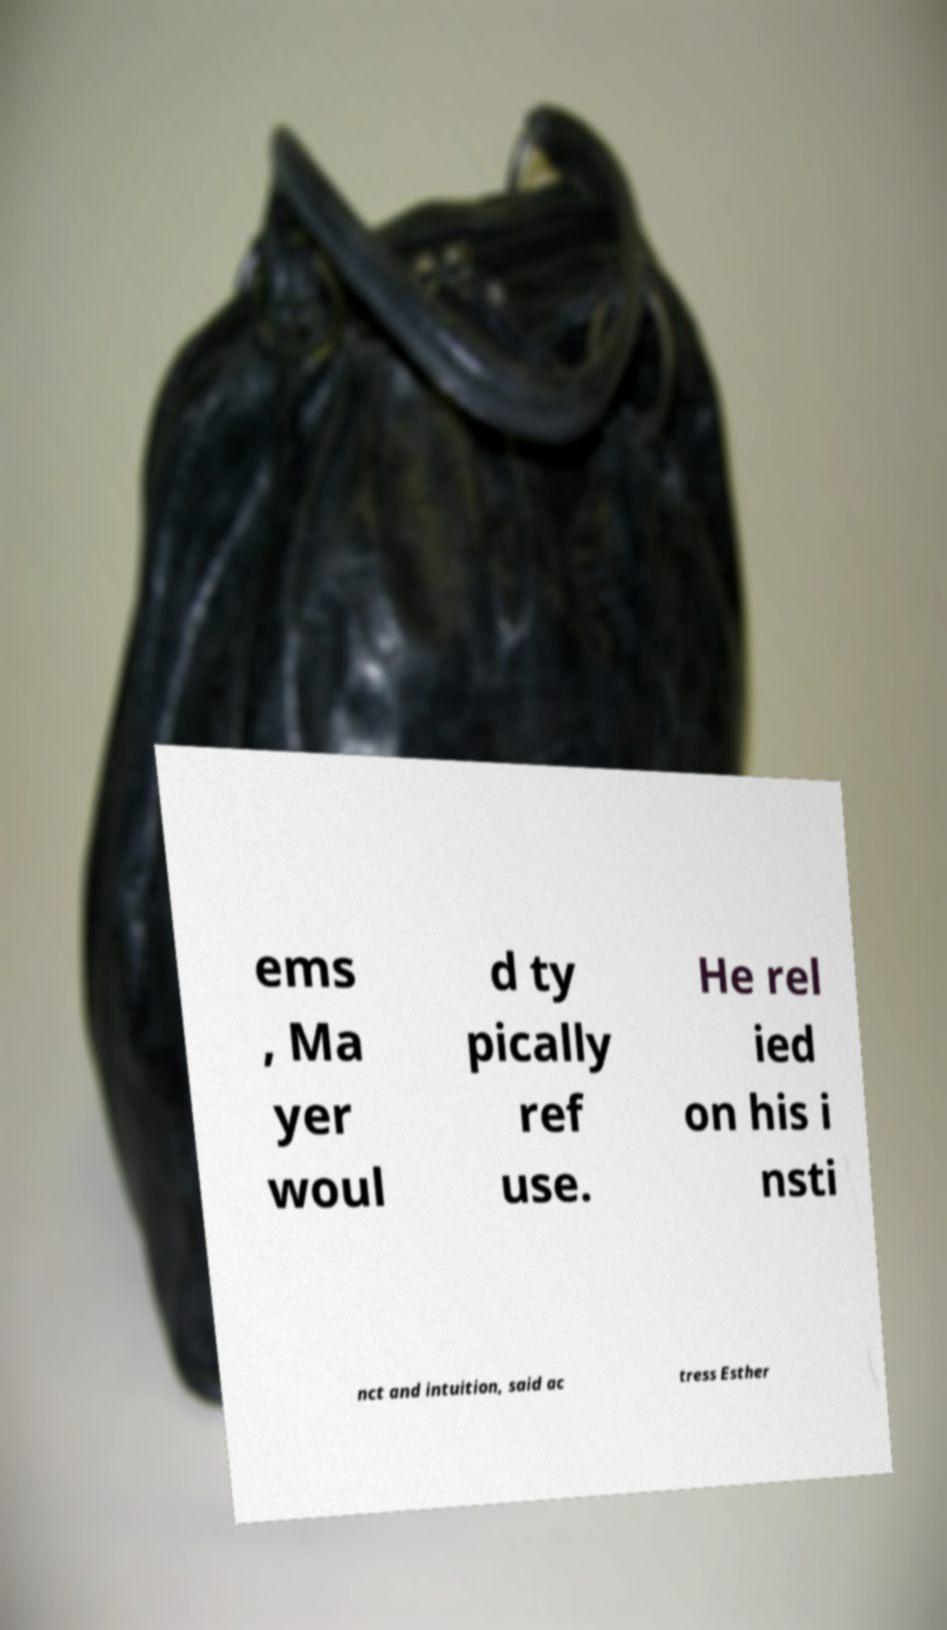What messages or text are displayed in this image? I need them in a readable, typed format. ems , Ma yer woul d ty pically ref use. He rel ied on his i nsti nct and intuition, said ac tress Esther 